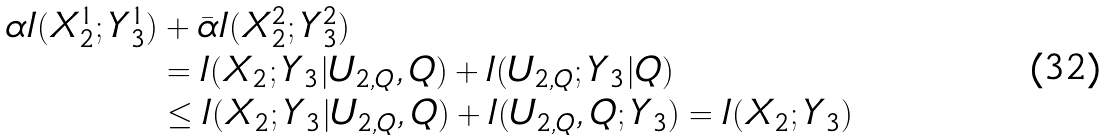<formula> <loc_0><loc_0><loc_500><loc_500>\alpha I ( X _ { 2 } ^ { 1 } ; Y _ { 3 } ^ { 1 } ) & + \bar { \alpha } I ( X _ { 2 } ^ { 2 } ; Y _ { 3 } ^ { 2 } ) \\ & = I ( X _ { 2 } ; Y _ { 3 } | U _ { 2 , Q } , Q ) + I ( U _ { 2 , Q } ; Y _ { 3 } | Q ) \\ & \leq I ( X _ { 2 } ; Y _ { 3 } | U _ { 2 , Q } , Q ) + I ( U _ { 2 , Q } , Q ; Y _ { 3 } ) = I ( X _ { 2 } ; Y _ { 3 } )</formula> 